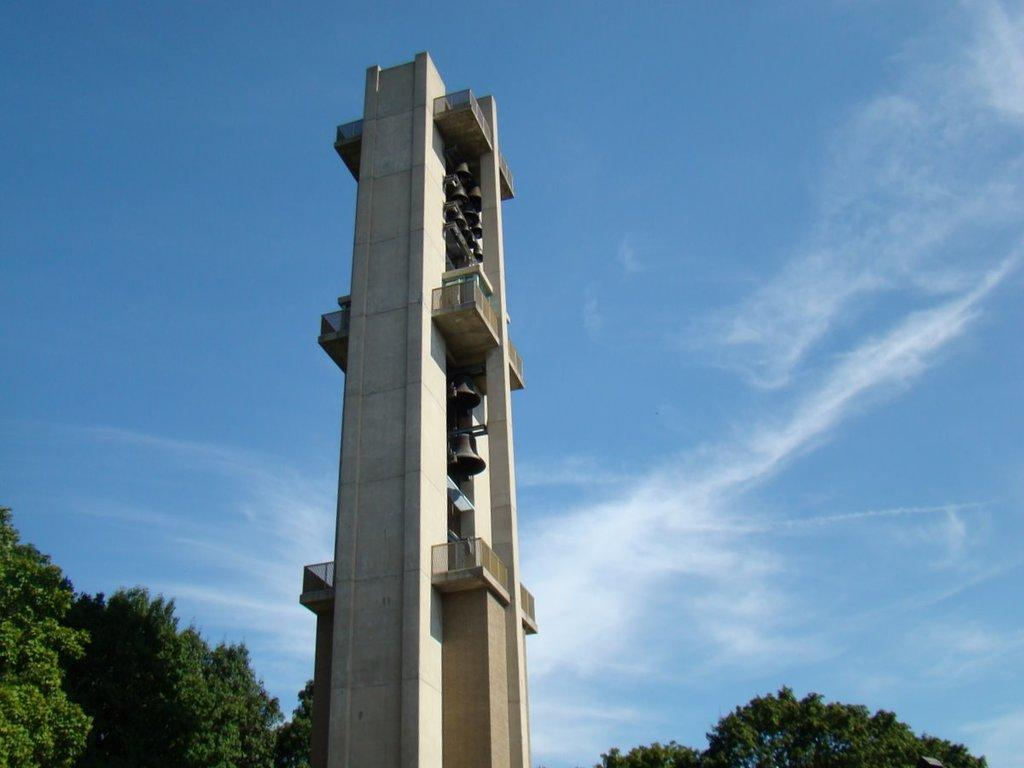What type of structure is present in the image? There is a concrete structure in the image. What feature can be seen on the structure? There is railing in the image. What beverages are present in the image? There are beers visible in the image. What type of vegetation is in the background of the image? There are trees in the background of the image. What is the color of the trees? The trees are green. What is the color of the sky in the image? The sky is blue and white in color. What type of suit is the powder wearing in the image? There is no suit or powder present in the image. 